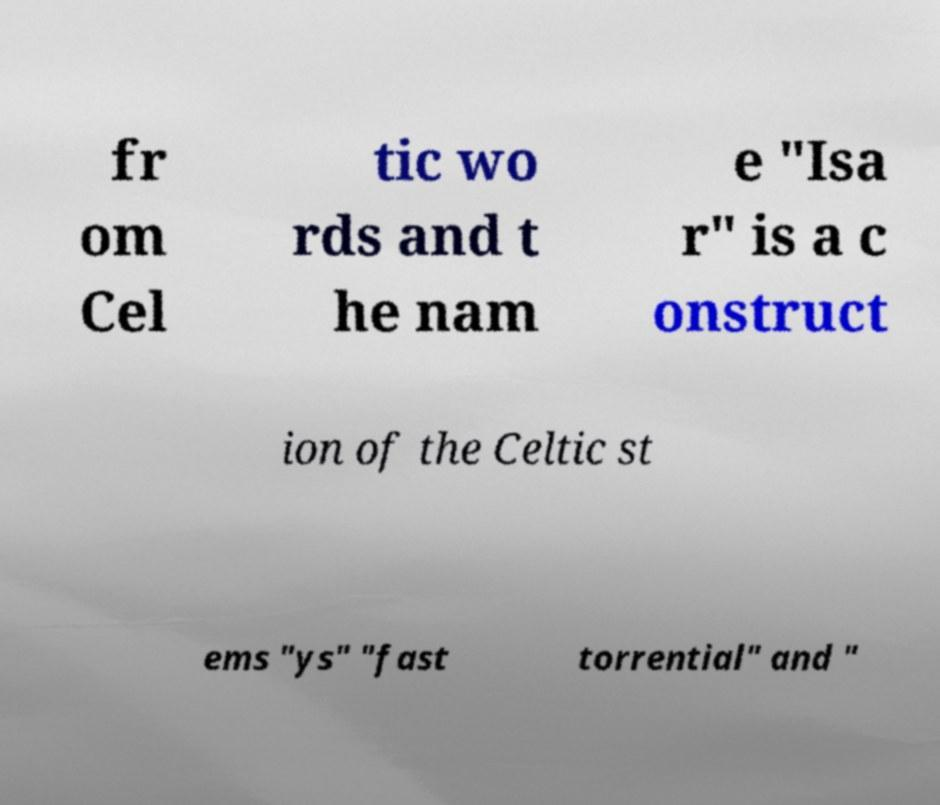Please read and relay the text visible in this image. What does it say? fr om Cel tic wo rds and t he nam e "Isa r" is a c onstruct ion of the Celtic st ems "ys" "fast torrential" and " 